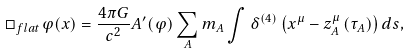Convert formula to latex. <formula><loc_0><loc_0><loc_500><loc_500>\Box _ { f l a t } \varphi ( x ) = \frac { 4 \pi G } { c ^ { 2 } } A ^ { \prime } ( \varphi ) \sum _ { A } m _ { A } \int \delta ^ { ( 4 ) } \left ( x ^ { \mu } - z _ { A } ^ { \mu } \left ( \tau _ { A } \right ) \right ) d s ,</formula> 